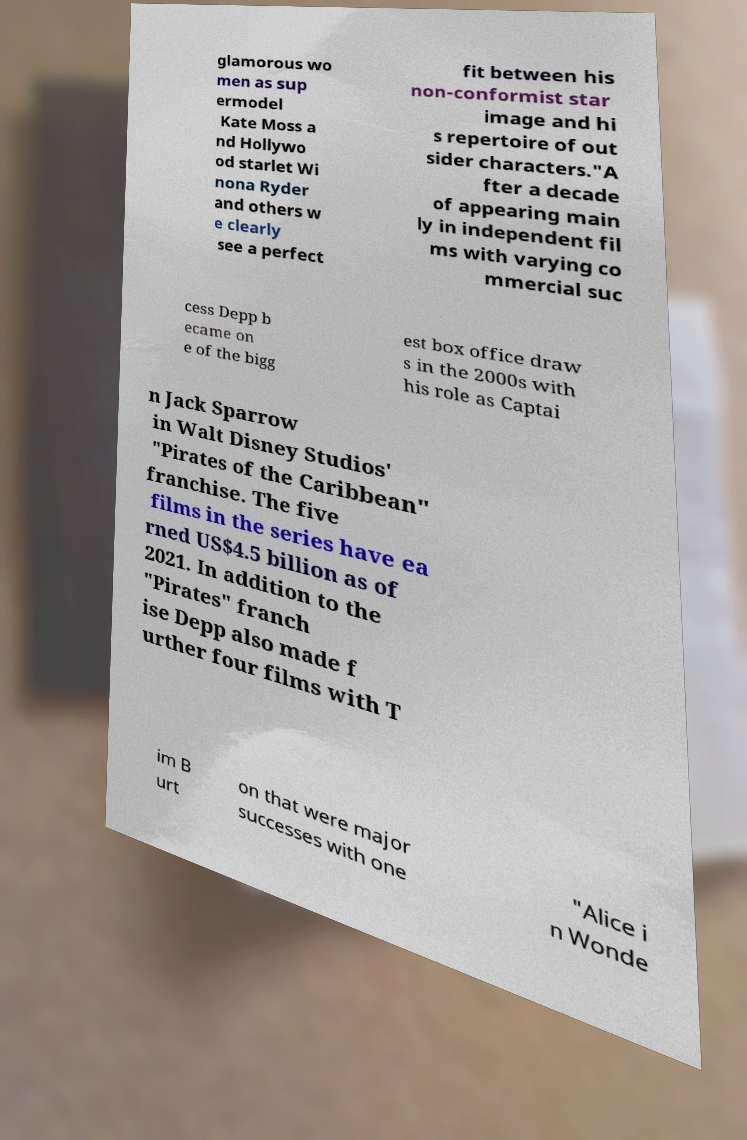There's text embedded in this image that I need extracted. Can you transcribe it verbatim? glamorous wo men as sup ermodel Kate Moss a nd Hollywo od starlet Wi nona Ryder and others w e clearly see a perfect fit between his non-conformist star image and hi s repertoire of out sider characters."A fter a decade of appearing main ly in independent fil ms with varying co mmercial suc cess Depp b ecame on e of the bigg est box office draw s in the 2000s with his role as Captai n Jack Sparrow in Walt Disney Studios' "Pirates of the Caribbean" franchise. The five films in the series have ea rned US$4.5 billion as of 2021. In addition to the "Pirates" franch ise Depp also made f urther four films with T im B urt on that were major successes with one "Alice i n Wonde 